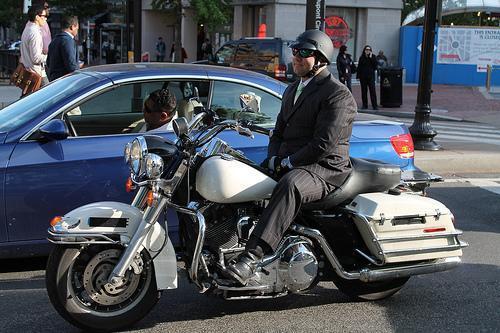How many people are in the blue car?
Give a very brief answer. 1. How many of the vehicles have only 2 wheels?
Give a very brief answer. 1. 